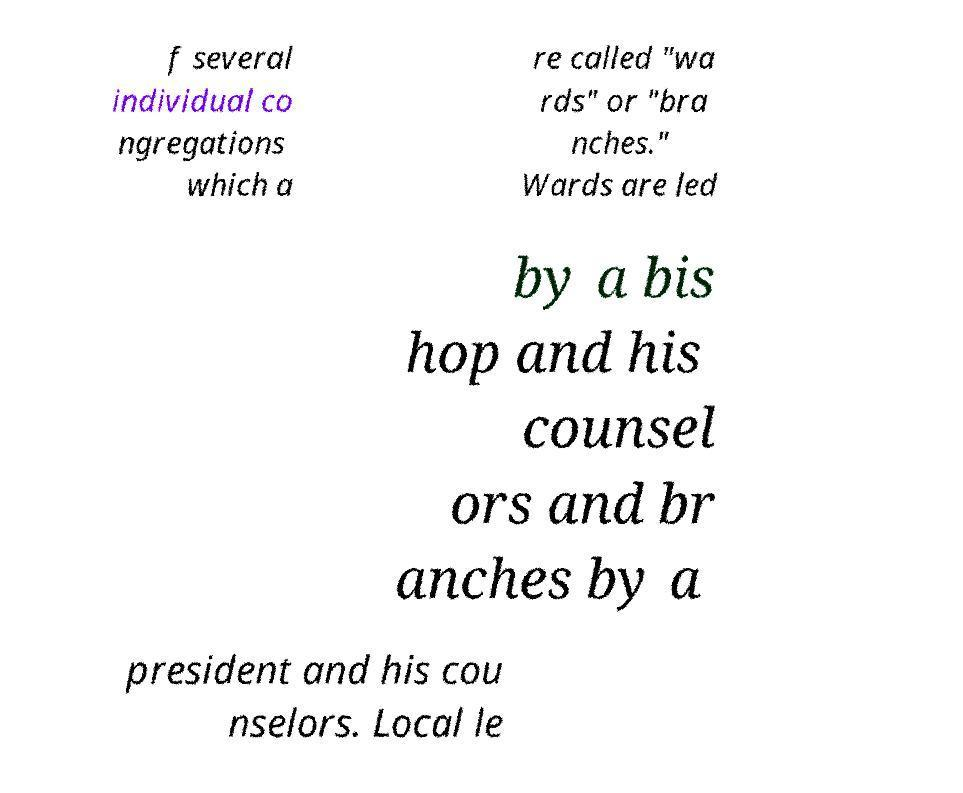Can you accurately transcribe the text from the provided image for me? f several individual co ngregations which a re called "wa rds" or "bra nches." Wards are led by a bis hop and his counsel ors and br anches by a president and his cou nselors. Local le 